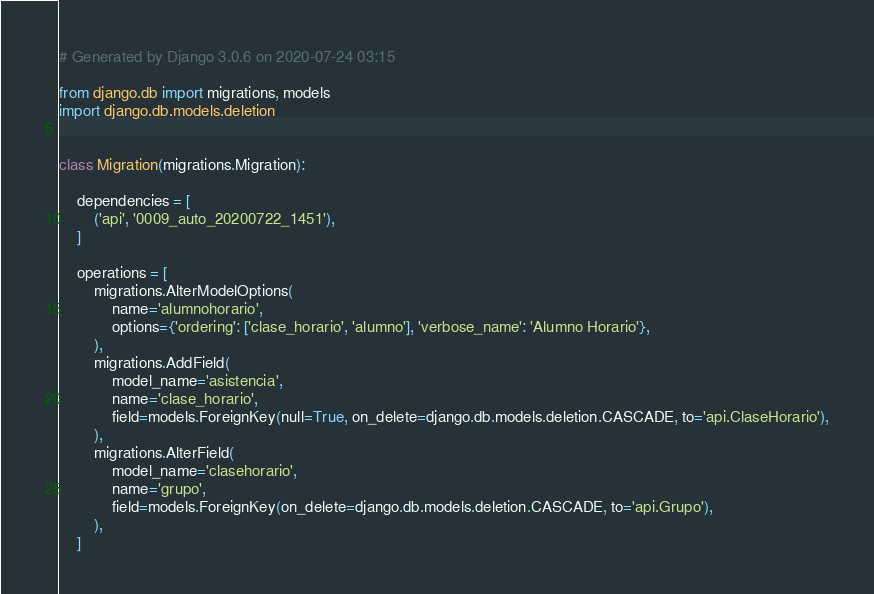<code> <loc_0><loc_0><loc_500><loc_500><_Python_># Generated by Django 3.0.6 on 2020-07-24 03:15

from django.db import migrations, models
import django.db.models.deletion


class Migration(migrations.Migration):

    dependencies = [
        ('api', '0009_auto_20200722_1451'),
    ]

    operations = [
        migrations.AlterModelOptions(
            name='alumnohorario',
            options={'ordering': ['clase_horario', 'alumno'], 'verbose_name': 'Alumno Horario'},
        ),
        migrations.AddField(
            model_name='asistencia',
            name='clase_horario',
            field=models.ForeignKey(null=True, on_delete=django.db.models.deletion.CASCADE, to='api.ClaseHorario'),
        ),
        migrations.AlterField(
            model_name='clasehorario',
            name='grupo',
            field=models.ForeignKey(on_delete=django.db.models.deletion.CASCADE, to='api.Grupo'),
        ),
    ]
</code> 